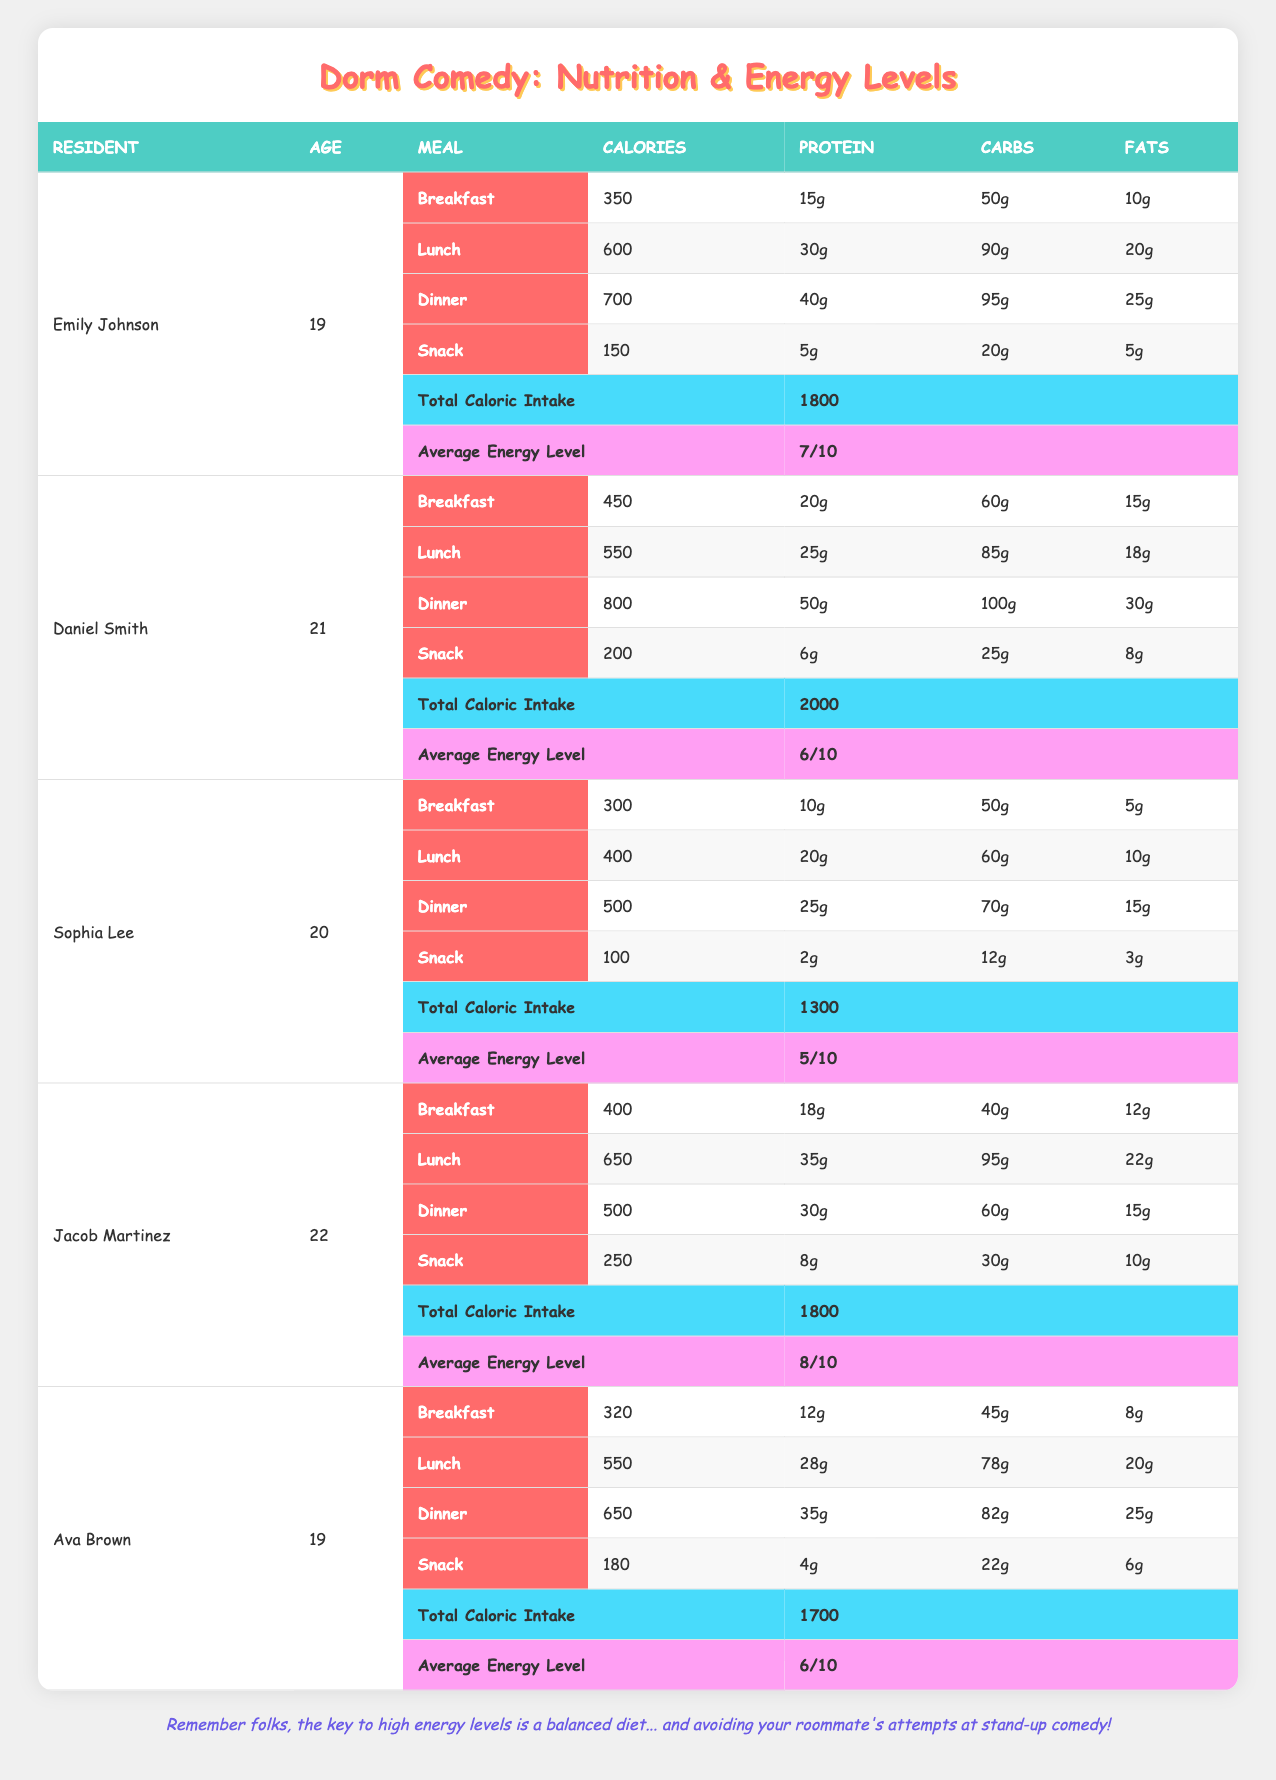What is the total caloric intake for Ava Brown? From the table, we can directly see that Ava Brown's total caloric intake is listed as 1700.
Answer: 1700 Which resident has the highest average energy level? Jacob Martinez has an average energy level of 8/10, which is higher than the others (Emily Johnson at 7/10, Daniel Smith at 6/10, Sophia Lee at 5/10, and Ava Brown at 6/10).
Answer: Jacob Martinez What is the average total caloric intake for the five residents? To find the average total caloric intake, we sum up all the total caloric intakes: 1800 + 2000 + 1300 + 1800 + 1700 = 10600. Next, we divide by the number of residents (5): 10600 / 5 = 2120.
Answer: 2120 Did Sophia Lee consume more calories for dinner than for lunch? Sophia Lee's dinner caloric intake is 500 while lunch is 400. Since 500 is greater than 400, the statement is true.
Answer: Yes What is the total protein intake from all meals for Daniel Smith? We sum up Daniel Smith's protein intake from each meal: Breakfast (20g) + Lunch (25g) + Dinner (50g) + Snack (6g) = 101g total protein.
Answer: 101g Which resident has the least amount of carbs in their breakfast? Sophia Lee has 50g of carbs in her breakfast, which is less than Emily Johnson (50g), Daniel Smith (60g), Jacob Martinez (40g), and Ava Brown (45g). Comparing the values shows that 40g (Jacob) is the least.
Answer: Jacob Martinez What is the difference in total caloric intake between Emily Johnson and Jacob Martinez? Emily Johnson's total caloric intake is 1800, and Jacob Martinez's is also 1800. The difference is calculated as 1800 - 1800 = 0.
Answer: 0 What percentage of Emily Johnson's total caloric intake comes from her dinner? Emily Johnson's dinner caloric intake is 700, which is divided by her total intake of 1800, then multiplied by 100: (700 / 1800) * 100 = 38.89%.
Answer: 38.89% 